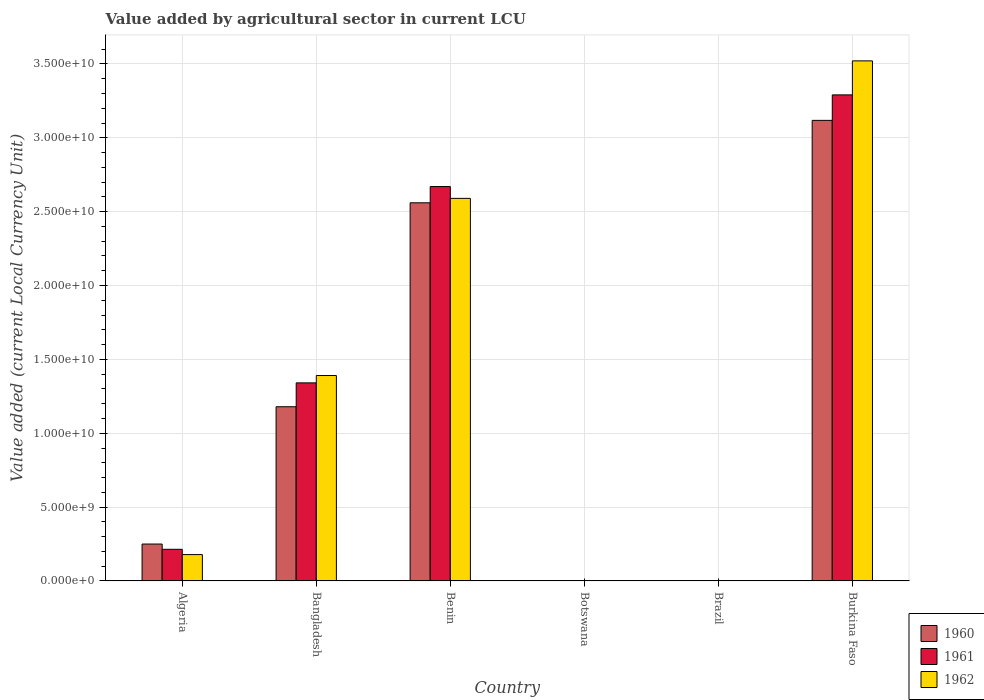How many different coloured bars are there?
Ensure brevity in your answer.  3. How many groups of bars are there?
Your response must be concise. 6. How many bars are there on the 4th tick from the right?
Ensure brevity in your answer.  3. What is the value added by agricultural sector in 1961 in Bangladesh?
Provide a succinct answer. 1.34e+1. Across all countries, what is the maximum value added by agricultural sector in 1962?
Offer a terse response. 3.52e+1. Across all countries, what is the minimum value added by agricultural sector in 1962?
Your response must be concise. 0. In which country was the value added by agricultural sector in 1961 maximum?
Provide a short and direct response. Burkina Faso. In which country was the value added by agricultural sector in 1960 minimum?
Give a very brief answer. Brazil. What is the total value added by agricultural sector in 1962 in the graph?
Offer a very short reply. 7.68e+1. What is the difference between the value added by agricultural sector in 1961 in Bangladesh and that in Burkina Faso?
Provide a short and direct response. -1.95e+1. What is the difference between the value added by agricultural sector in 1962 in Burkina Faso and the value added by agricultural sector in 1960 in Botswana?
Provide a succinct answer. 3.52e+1. What is the average value added by agricultural sector in 1960 per country?
Provide a succinct answer. 1.18e+1. What is the difference between the value added by agricultural sector of/in 1960 and value added by agricultural sector of/in 1961 in Burkina Faso?
Make the answer very short. -1.73e+09. In how many countries, is the value added by agricultural sector in 1962 greater than 24000000000 LCU?
Your answer should be compact. 2. What is the ratio of the value added by agricultural sector in 1960 in Algeria to that in Benin?
Make the answer very short. 0.1. Is the value added by agricultural sector in 1962 in Algeria less than that in Burkina Faso?
Keep it short and to the point. Yes. Is the difference between the value added by agricultural sector in 1960 in Bangladesh and Botswana greater than the difference between the value added by agricultural sector in 1961 in Bangladesh and Botswana?
Offer a terse response. No. What is the difference between the highest and the second highest value added by agricultural sector in 1961?
Keep it short and to the point. 6.21e+09. What is the difference between the highest and the lowest value added by agricultural sector in 1961?
Your response must be concise. 3.29e+1. Is the sum of the value added by agricultural sector in 1961 in Bangladesh and Benin greater than the maximum value added by agricultural sector in 1960 across all countries?
Offer a terse response. Yes. What does the 2nd bar from the right in Burkina Faso represents?
Offer a very short reply. 1961. How many countries are there in the graph?
Your answer should be very brief. 6. What is the difference between two consecutive major ticks on the Y-axis?
Offer a terse response. 5.00e+09. Does the graph contain any zero values?
Your response must be concise. No. How are the legend labels stacked?
Your answer should be compact. Vertical. What is the title of the graph?
Make the answer very short. Value added by agricultural sector in current LCU. What is the label or title of the Y-axis?
Your response must be concise. Value added (current Local Currency Unit). What is the Value added (current Local Currency Unit) of 1960 in Algeria?
Offer a very short reply. 2.50e+09. What is the Value added (current Local Currency Unit) in 1961 in Algeria?
Ensure brevity in your answer.  2.14e+09. What is the Value added (current Local Currency Unit) in 1962 in Algeria?
Offer a terse response. 1.78e+09. What is the Value added (current Local Currency Unit) of 1960 in Bangladesh?
Your answer should be very brief. 1.18e+1. What is the Value added (current Local Currency Unit) in 1961 in Bangladesh?
Your answer should be compact. 1.34e+1. What is the Value added (current Local Currency Unit) in 1962 in Bangladesh?
Your answer should be very brief. 1.39e+1. What is the Value added (current Local Currency Unit) of 1960 in Benin?
Offer a very short reply. 2.56e+1. What is the Value added (current Local Currency Unit) in 1961 in Benin?
Your response must be concise. 2.67e+1. What is the Value added (current Local Currency Unit) of 1962 in Benin?
Make the answer very short. 2.59e+1. What is the Value added (current Local Currency Unit) in 1960 in Botswana?
Your answer should be very brief. 9.38e+06. What is the Value added (current Local Currency Unit) in 1961 in Botswana?
Your response must be concise. 9.86e+06. What is the Value added (current Local Currency Unit) in 1962 in Botswana?
Offer a very short reply. 1.03e+07. What is the Value added (current Local Currency Unit) of 1960 in Brazil?
Keep it short and to the point. 0. What is the Value added (current Local Currency Unit) of 1961 in Brazil?
Keep it short and to the point. 0. What is the Value added (current Local Currency Unit) of 1962 in Brazil?
Offer a very short reply. 0. What is the Value added (current Local Currency Unit) of 1960 in Burkina Faso?
Your answer should be very brief. 3.12e+1. What is the Value added (current Local Currency Unit) in 1961 in Burkina Faso?
Your answer should be compact. 3.29e+1. What is the Value added (current Local Currency Unit) in 1962 in Burkina Faso?
Provide a succinct answer. 3.52e+1. Across all countries, what is the maximum Value added (current Local Currency Unit) of 1960?
Offer a terse response. 3.12e+1. Across all countries, what is the maximum Value added (current Local Currency Unit) in 1961?
Your answer should be compact. 3.29e+1. Across all countries, what is the maximum Value added (current Local Currency Unit) in 1962?
Provide a succinct answer. 3.52e+1. Across all countries, what is the minimum Value added (current Local Currency Unit) of 1960?
Provide a short and direct response. 0. Across all countries, what is the minimum Value added (current Local Currency Unit) in 1961?
Offer a very short reply. 0. Across all countries, what is the minimum Value added (current Local Currency Unit) of 1962?
Your answer should be compact. 0. What is the total Value added (current Local Currency Unit) in 1960 in the graph?
Your answer should be compact. 7.11e+1. What is the total Value added (current Local Currency Unit) in 1961 in the graph?
Give a very brief answer. 7.52e+1. What is the total Value added (current Local Currency Unit) of 1962 in the graph?
Your answer should be compact. 7.68e+1. What is the difference between the Value added (current Local Currency Unit) in 1960 in Algeria and that in Bangladesh?
Make the answer very short. -9.29e+09. What is the difference between the Value added (current Local Currency Unit) in 1961 in Algeria and that in Bangladesh?
Offer a terse response. -1.13e+1. What is the difference between the Value added (current Local Currency Unit) of 1962 in Algeria and that in Bangladesh?
Your answer should be compact. -1.21e+1. What is the difference between the Value added (current Local Currency Unit) in 1960 in Algeria and that in Benin?
Make the answer very short. -2.31e+1. What is the difference between the Value added (current Local Currency Unit) of 1961 in Algeria and that in Benin?
Make the answer very short. -2.46e+1. What is the difference between the Value added (current Local Currency Unit) of 1962 in Algeria and that in Benin?
Make the answer very short. -2.41e+1. What is the difference between the Value added (current Local Currency Unit) in 1960 in Algeria and that in Botswana?
Provide a succinct answer. 2.49e+09. What is the difference between the Value added (current Local Currency Unit) of 1961 in Algeria and that in Botswana?
Your answer should be compact. 2.13e+09. What is the difference between the Value added (current Local Currency Unit) in 1962 in Algeria and that in Botswana?
Provide a succinct answer. 1.77e+09. What is the difference between the Value added (current Local Currency Unit) in 1960 in Algeria and that in Brazil?
Your answer should be compact. 2.50e+09. What is the difference between the Value added (current Local Currency Unit) of 1961 in Algeria and that in Brazil?
Your response must be concise. 2.14e+09. What is the difference between the Value added (current Local Currency Unit) of 1962 in Algeria and that in Brazil?
Provide a short and direct response. 1.78e+09. What is the difference between the Value added (current Local Currency Unit) of 1960 in Algeria and that in Burkina Faso?
Provide a short and direct response. -2.87e+1. What is the difference between the Value added (current Local Currency Unit) in 1961 in Algeria and that in Burkina Faso?
Your answer should be compact. -3.08e+1. What is the difference between the Value added (current Local Currency Unit) of 1962 in Algeria and that in Burkina Faso?
Your answer should be very brief. -3.34e+1. What is the difference between the Value added (current Local Currency Unit) in 1960 in Bangladesh and that in Benin?
Offer a terse response. -1.38e+1. What is the difference between the Value added (current Local Currency Unit) in 1961 in Bangladesh and that in Benin?
Offer a terse response. -1.33e+1. What is the difference between the Value added (current Local Currency Unit) in 1962 in Bangladesh and that in Benin?
Ensure brevity in your answer.  -1.20e+1. What is the difference between the Value added (current Local Currency Unit) of 1960 in Bangladesh and that in Botswana?
Offer a terse response. 1.18e+1. What is the difference between the Value added (current Local Currency Unit) of 1961 in Bangladesh and that in Botswana?
Provide a succinct answer. 1.34e+1. What is the difference between the Value added (current Local Currency Unit) of 1962 in Bangladesh and that in Botswana?
Make the answer very short. 1.39e+1. What is the difference between the Value added (current Local Currency Unit) in 1960 in Bangladesh and that in Brazil?
Your answer should be very brief. 1.18e+1. What is the difference between the Value added (current Local Currency Unit) in 1961 in Bangladesh and that in Brazil?
Your answer should be compact. 1.34e+1. What is the difference between the Value added (current Local Currency Unit) in 1962 in Bangladesh and that in Brazil?
Keep it short and to the point. 1.39e+1. What is the difference between the Value added (current Local Currency Unit) of 1960 in Bangladesh and that in Burkina Faso?
Your response must be concise. -1.94e+1. What is the difference between the Value added (current Local Currency Unit) of 1961 in Bangladesh and that in Burkina Faso?
Give a very brief answer. -1.95e+1. What is the difference between the Value added (current Local Currency Unit) of 1962 in Bangladesh and that in Burkina Faso?
Ensure brevity in your answer.  -2.13e+1. What is the difference between the Value added (current Local Currency Unit) of 1960 in Benin and that in Botswana?
Make the answer very short. 2.56e+1. What is the difference between the Value added (current Local Currency Unit) of 1961 in Benin and that in Botswana?
Make the answer very short. 2.67e+1. What is the difference between the Value added (current Local Currency Unit) in 1962 in Benin and that in Botswana?
Give a very brief answer. 2.59e+1. What is the difference between the Value added (current Local Currency Unit) of 1960 in Benin and that in Brazil?
Your answer should be compact. 2.56e+1. What is the difference between the Value added (current Local Currency Unit) of 1961 in Benin and that in Brazil?
Keep it short and to the point. 2.67e+1. What is the difference between the Value added (current Local Currency Unit) in 1962 in Benin and that in Brazil?
Give a very brief answer. 2.59e+1. What is the difference between the Value added (current Local Currency Unit) in 1960 in Benin and that in Burkina Faso?
Your response must be concise. -5.58e+09. What is the difference between the Value added (current Local Currency Unit) of 1961 in Benin and that in Burkina Faso?
Your answer should be very brief. -6.21e+09. What is the difference between the Value added (current Local Currency Unit) of 1962 in Benin and that in Burkina Faso?
Your response must be concise. -9.31e+09. What is the difference between the Value added (current Local Currency Unit) in 1960 in Botswana and that in Brazil?
Provide a succinct answer. 9.38e+06. What is the difference between the Value added (current Local Currency Unit) in 1961 in Botswana and that in Brazil?
Your answer should be compact. 9.86e+06. What is the difference between the Value added (current Local Currency Unit) of 1962 in Botswana and that in Brazil?
Provide a succinct answer. 1.03e+07. What is the difference between the Value added (current Local Currency Unit) of 1960 in Botswana and that in Burkina Faso?
Your answer should be compact. -3.12e+1. What is the difference between the Value added (current Local Currency Unit) in 1961 in Botswana and that in Burkina Faso?
Provide a succinct answer. -3.29e+1. What is the difference between the Value added (current Local Currency Unit) in 1962 in Botswana and that in Burkina Faso?
Make the answer very short. -3.52e+1. What is the difference between the Value added (current Local Currency Unit) of 1960 in Brazil and that in Burkina Faso?
Your response must be concise. -3.12e+1. What is the difference between the Value added (current Local Currency Unit) of 1961 in Brazil and that in Burkina Faso?
Provide a short and direct response. -3.29e+1. What is the difference between the Value added (current Local Currency Unit) of 1962 in Brazil and that in Burkina Faso?
Your answer should be compact. -3.52e+1. What is the difference between the Value added (current Local Currency Unit) in 1960 in Algeria and the Value added (current Local Currency Unit) in 1961 in Bangladesh?
Give a very brief answer. -1.09e+1. What is the difference between the Value added (current Local Currency Unit) of 1960 in Algeria and the Value added (current Local Currency Unit) of 1962 in Bangladesh?
Your response must be concise. -1.14e+1. What is the difference between the Value added (current Local Currency Unit) in 1961 in Algeria and the Value added (current Local Currency Unit) in 1962 in Bangladesh?
Your answer should be compact. -1.18e+1. What is the difference between the Value added (current Local Currency Unit) of 1960 in Algeria and the Value added (current Local Currency Unit) of 1961 in Benin?
Ensure brevity in your answer.  -2.42e+1. What is the difference between the Value added (current Local Currency Unit) of 1960 in Algeria and the Value added (current Local Currency Unit) of 1962 in Benin?
Offer a very short reply. -2.34e+1. What is the difference between the Value added (current Local Currency Unit) of 1961 in Algeria and the Value added (current Local Currency Unit) of 1962 in Benin?
Your answer should be compact. -2.38e+1. What is the difference between the Value added (current Local Currency Unit) in 1960 in Algeria and the Value added (current Local Currency Unit) in 1961 in Botswana?
Ensure brevity in your answer.  2.49e+09. What is the difference between the Value added (current Local Currency Unit) of 1960 in Algeria and the Value added (current Local Currency Unit) of 1962 in Botswana?
Give a very brief answer. 2.49e+09. What is the difference between the Value added (current Local Currency Unit) in 1961 in Algeria and the Value added (current Local Currency Unit) in 1962 in Botswana?
Your response must be concise. 2.13e+09. What is the difference between the Value added (current Local Currency Unit) in 1960 in Algeria and the Value added (current Local Currency Unit) in 1961 in Brazil?
Your answer should be very brief. 2.50e+09. What is the difference between the Value added (current Local Currency Unit) in 1960 in Algeria and the Value added (current Local Currency Unit) in 1962 in Brazil?
Make the answer very short. 2.50e+09. What is the difference between the Value added (current Local Currency Unit) of 1961 in Algeria and the Value added (current Local Currency Unit) of 1962 in Brazil?
Ensure brevity in your answer.  2.14e+09. What is the difference between the Value added (current Local Currency Unit) in 1960 in Algeria and the Value added (current Local Currency Unit) in 1961 in Burkina Faso?
Give a very brief answer. -3.04e+1. What is the difference between the Value added (current Local Currency Unit) in 1960 in Algeria and the Value added (current Local Currency Unit) in 1962 in Burkina Faso?
Your answer should be very brief. -3.27e+1. What is the difference between the Value added (current Local Currency Unit) of 1961 in Algeria and the Value added (current Local Currency Unit) of 1962 in Burkina Faso?
Give a very brief answer. -3.31e+1. What is the difference between the Value added (current Local Currency Unit) of 1960 in Bangladesh and the Value added (current Local Currency Unit) of 1961 in Benin?
Ensure brevity in your answer.  -1.49e+1. What is the difference between the Value added (current Local Currency Unit) in 1960 in Bangladesh and the Value added (current Local Currency Unit) in 1962 in Benin?
Give a very brief answer. -1.41e+1. What is the difference between the Value added (current Local Currency Unit) in 1961 in Bangladesh and the Value added (current Local Currency Unit) in 1962 in Benin?
Offer a terse response. -1.25e+1. What is the difference between the Value added (current Local Currency Unit) in 1960 in Bangladesh and the Value added (current Local Currency Unit) in 1961 in Botswana?
Ensure brevity in your answer.  1.18e+1. What is the difference between the Value added (current Local Currency Unit) in 1960 in Bangladesh and the Value added (current Local Currency Unit) in 1962 in Botswana?
Offer a very short reply. 1.18e+1. What is the difference between the Value added (current Local Currency Unit) of 1961 in Bangladesh and the Value added (current Local Currency Unit) of 1962 in Botswana?
Offer a very short reply. 1.34e+1. What is the difference between the Value added (current Local Currency Unit) of 1960 in Bangladesh and the Value added (current Local Currency Unit) of 1961 in Brazil?
Your response must be concise. 1.18e+1. What is the difference between the Value added (current Local Currency Unit) of 1960 in Bangladesh and the Value added (current Local Currency Unit) of 1962 in Brazil?
Offer a very short reply. 1.18e+1. What is the difference between the Value added (current Local Currency Unit) of 1961 in Bangladesh and the Value added (current Local Currency Unit) of 1962 in Brazil?
Your response must be concise. 1.34e+1. What is the difference between the Value added (current Local Currency Unit) in 1960 in Bangladesh and the Value added (current Local Currency Unit) in 1961 in Burkina Faso?
Your answer should be very brief. -2.11e+1. What is the difference between the Value added (current Local Currency Unit) in 1960 in Bangladesh and the Value added (current Local Currency Unit) in 1962 in Burkina Faso?
Provide a short and direct response. -2.34e+1. What is the difference between the Value added (current Local Currency Unit) of 1961 in Bangladesh and the Value added (current Local Currency Unit) of 1962 in Burkina Faso?
Offer a very short reply. -2.18e+1. What is the difference between the Value added (current Local Currency Unit) of 1960 in Benin and the Value added (current Local Currency Unit) of 1961 in Botswana?
Your response must be concise. 2.56e+1. What is the difference between the Value added (current Local Currency Unit) in 1960 in Benin and the Value added (current Local Currency Unit) in 1962 in Botswana?
Provide a succinct answer. 2.56e+1. What is the difference between the Value added (current Local Currency Unit) in 1961 in Benin and the Value added (current Local Currency Unit) in 1962 in Botswana?
Your response must be concise. 2.67e+1. What is the difference between the Value added (current Local Currency Unit) in 1960 in Benin and the Value added (current Local Currency Unit) in 1961 in Brazil?
Offer a very short reply. 2.56e+1. What is the difference between the Value added (current Local Currency Unit) of 1960 in Benin and the Value added (current Local Currency Unit) of 1962 in Brazil?
Offer a very short reply. 2.56e+1. What is the difference between the Value added (current Local Currency Unit) in 1961 in Benin and the Value added (current Local Currency Unit) in 1962 in Brazil?
Give a very brief answer. 2.67e+1. What is the difference between the Value added (current Local Currency Unit) of 1960 in Benin and the Value added (current Local Currency Unit) of 1961 in Burkina Faso?
Your response must be concise. -7.31e+09. What is the difference between the Value added (current Local Currency Unit) in 1960 in Benin and the Value added (current Local Currency Unit) in 1962 in Burkina Faso?
Offer a terse response. -9.61e+09. What is the difference between the Value added (current Local Currency Unit) of 1961 in Benin and the Value added (current Local Currency Unit) of 1962 in Burkina Faso?
Offer a terse response. -8.51e+09. What is the difference between the Value added (current Local Currency Unit) of 1960 in Botswana and the Value added (current Local Currency Unit) of 1961 in Brazil?
Offer a very short reply. 9.38e+06. What is the difference between the Value added (current Local Currency Unit) in 1960 in Botswana and the Value added (current Local Currency Unit) in 1962 in Brazil?
Your response must be concise. 9.38e+06. What is the difference between the Value added (current Local Currency Unit) in 1961 in Botswana and the Value added (current Local Currency Unit) in 1962 in Brazil?
Your answer should be compact. 9.86e+06. What is the difference between the Value added (current Local Currency Unit) of 1960 in Botswana and the Value added (current Local Currency Unit) of 1961 in Burkina Faso?
Provide a succinct answer. -3.29e+1. What is the difference between the Value added (current Local Currency Unit) in 1960 in Botswana and the Value added (current Local Currency Unit) in 1962 in Burkina Faso?
Ensure brevity in your answer.  -3.52e+1. What is the difference between the Value added (current Local Currency Unit) of 1961 in Botswana and the Value added (current Local Currency Unit) of 1962 in Burkina Faso?
Keep it short and to the point. -3.52e+1. What is the difference between the Value added (current Local Currency Unit) in 1960 in Brazil and the Value added (current Local Currency Unit) in 1961 in Burkina Faso?
Your answer should be compact. -3.29e+1. What is the difference between the Value added (current Local Currency Unit) in 1960 in Brazil and the Value added (current Local Currency Unit) in 1962 in Burkina Faso?
Provide a succinct answer. -3.52e+1. What is the difference between the Value added (current Local Currency Unit) in 1961 in Brazil and the Value added (current Local Currency Unit) in 1962 in Burkina Faso?
Ensure brevity in your answer.  -3.52e+1. What is the average Value added (current Local Currency Unit) in 1960 per country?
Your response must be concise. 1.18e+1. What is the average Value added (current Local Currency Unit) in 1961 per country?
Your answer should be very brief. 1.25e+1. What is the average Value added (current Local Currency Unit) in 1962 per country?
Give a very brief answer. 1.28e+1. What is the difference between the Value added (current Local Currency Unit) of 1960 and Value added (current Local Currency Unit) of 1961 in Algeria?
Offer a terse response. 3.57e+08. What is the difference between the Value added (current Local Currency Unit) of 1960 and Value added (current Local Currency Unit) of 1962 in Algeria?
Your response must be concise. 7.14e+08. What is the difference between the Value added (current Local Currency Unit) in 1961 and Value added (current Local Currency Unit) in 1962 in Algeria?
Provide a short and direct response. 3.57e+08. What is the difference between the Value added (current Local Currency Unit) of 1960 and Value added (current Local Currency Unit) of 1961 in Bangladesh?
Provide a short and direct response. -1.62e+09. What is the difference between the Value added (current Local Currency Unit) of 1960 and Value added (current Local Currency Unit) of 1962 in Bangladesh?
Your answer should be very brief. -2.11e+09. What is the difference between the Value added (current Local Currency Unit) in 1961 and Value added (current Local Currency Unit) in 1962 in Bangladesh?
Your answer should be very brief. -4.98e+08. What is the difference between the Value added (current Local Currency Unit) of 1960 and Value added (current Local Currency Unit) of 1961 in Benin?
Make the answer very short. -1.10e+09. What is the difference between the Value added (current Local Currency Unit) in 1960 and Value added (current Local Currency Unit) in 1962 in Benin?
Offer a terse response. -3.00e+08. What is the difference between the Value added (current Local Currency Unit) in 1961 and Value added (current Local Currency Unit) in 1962 in Benin?
Keep it short and to the point. 8.00e+08. What is the difference between the Value added (current Local Currency Unit) of 1960 and Value added (current Local Currency Unit) of 1961 in Botswana?
Your answer should be compact. -4.83e+05. What is the difference between the Value added (current Local Currency Unit) of 1960 and Value added (current Local Currency Unit) of 1962 in Botswana?
Make the answer very short. -9.65e+05. What is the difference between the Value added (current Local Currency Unit) of 1961 and Value added (current Local Currency Unit) of 1962 in Botswana?
Your answer should be compact. -4.83e+05. What is the difference between the Value added (current Local Currency Unit) in 1960 and Value added (current Local Currency Unit) in 1961 in Brazil?
Provide a succinct answer. -0. What is the difference between the Value added (current Local Currency Unit) in 1960 and Value added (current Local Currency Unit) in 1962 in Brazil?
Make the answer very short. -0. What is the difference between the Value added (current Local Currency Unit) in 1961 and Value added (current Local Currency Unit) in 1962 in Brazil?
Make the answer very short. -0. What is the difference between the Value added (current Local Currency Unit) of 1960 and Value added (current Local Currency Unit) of 1961 in Burkina Faso?
Provide a short and direct response. -1.73e+09. What is the difference between the Value added (current Local Currency Unit) of 1960 and Value added (current Local Currency Unit) of 1962 in Burkina Faso?
Offer a terse response. -4.03e+09. What is the difference between the Value added (current Local Currency Unit) of 1961 and Value added (current Local Currency Unit) of 1962 in Burkina Faso?
Make the answer very short. -2.30e+09. What is the ratio of the Value added (current Local Currency Unit) of 1960 in Algeria to that in Bangladesh?
Provide a short and direct response. 0.21. What is the ratio of the Value added (current Local Currency Unit) of 1961 in Algeria to that in Bangladesh?
Your answer should be compact. 0.16. What is the ratio of the Value added (current Local Currency Unit) in 1962 in Algeria to that in Bangladesh?
Your response must be concise. 0.13. What is the ratio of the Value added (current Local Currency Unit) of 1960 in Algeria to that in Benin?
Your answer should be very brief. 0.1. What is the ratio of the Value added (current Local Currency Unit) of 1961 in Algeria to that in Benin?
Your answer should be compact. 0.08. What is the ratio of the Value added (current Local Currency Unit) in 1962 in Algeria to that in Benin?
Your response must be concise. 0.07. What is the ratio of the Value added (current Local Currency Unit) of 1960 in Algeria to that in Botswana?
Ensure brevity in your answer.  266.47. What is the ratio of the Value added (current Local Currency Unit) in 1961 in Algeria to that in Botswana?
Your response must be concise. 217.22. What is the ratio of the Value added (current Local Currency Unit) of 1962 in Algeria to that in Botswana?
Offer a terse response. 172.57. What is the ratio of the Value added (current Local Currency Unit) in 1960 in Algeria to that in Brazil?
Ensure brevity in your answer.  1.37e+13. What is the ratio of the Value added (current Local Currency Unit) of 1961 in Algeria to that in Brazil?
Offer a very short reply. 8.40e+12. What is the ratio of the Value added (current Local Currency Unit) in 1962 in Algeria to that in Brazil?
Offer a terse response. 4.09e+12. What is the ratio of the Value added (current Local Currency Unit) of 1960 in Algeria to that in Burkina Faso?
Offer a very short reply. 0.08. What is the ratio of the Value added (current Local Currency Unit) of 1961 in Algeria to that in Burkina Faso?
Your answer should be very brief. 0.07. What is the ratio of the Value added (current Local Currency Unit) in 1962 in Algeria to that in Burkina Faso?
Your answer should be very brief. 0.05. What is the ratio of the Value added (current Local Currency Unit) in 1960 in Bangladesh to that in Benin?
Offer a very short reply. 0.46. What is the ratio of the Value added (current Local Currency Unit) in 1961 in Bangladesh to that in Benin?
Make the answer very short. 0.5. What is the ratio of the Value added (current Local Currency Unit) in 1962 in Bangladesh to that in Benin?
Your answer should be very brief. 0.54. What is the ratio of the Value added (current Local Currency Unit) of 1960 in Bangladesh to that in Botswana?
Provide a short and direct response. 1257.78. What is the ratio of the Value added (current Local Currency Unit) in 1961 in Bangladesh to that in Botswana?
Your answer should be very brief. 1360.12. What is the ratio of the Value added (current Local Currency Unit) of 1962 in Bangladesh to that in Botswana?
Ensure brevity in your answer.  1344.79. What is the ratio of the Value added (current Local Currency Unit) of 1960 in Bangladesh to that in Brazil?
Your response must be concise. 6.48e+13. What is the ratio of the Value added (current Local Currency Unit) in 1961 in Bangladesh to that in Brazil?
Ensure brevity in your answer.  5.26e+13. What is the ratio of the Value added (current Local Currency Unit) of 1962 in Bangladesh to that in Brazil?
Provide a succinct answer. 3.19e+13. What is the ratio of the Value added (current Local Currency Unit) of 1960 in Bangladesh to that in Burkina Faso?
Your answer should be very brief. 0.38. What is the ratio of the Value added (current Local Currency Unit) in 1961 in Bangladesh to that in Burkina Faso?
Make the answer very short. 0.41. What is the ratio of the Value added (current Local Currency Unit) in 1962 in Bangladesh to that in Burkina Faso?
Provide a succinct answer. 0.4. What is the ratio of the Value added (current Local Currency Unit) in 1960 in Benin to that in Botswana?
Your response must be concise. 2730.26. What is the ratio of the Value added (current Local Currency Unit) of 1961 in Benin to that in Botswana?
Offer a very short reply. 2708.19. What is the ratio of the Value added (current Local Currency Unit) in 1962 in Benin to that in Botswana?
Make the answer very short. 2504.45. What is the ratio of the Value added (current Local Currency Unit) of 1960 in Benin to that in Brazil?
Offer a terse response. 1.41e+14. What is the ratio of the Value added (current Local Currency Unit) in 1961 in Benin to that in Brazil?
Provide a succinct answer. 1.05e+14. What is the ratio of the Value added (current Local Currency Unit) in 1962 in Benin to that in Brazil?
Ensure brevity in your answer.  5.94e+13. What is the ratio of the Value added (current Local Currency Unit) of 1960 in Benin to that in Burkina Faso?
Your answer should be very brief. 0.82. What is the ratio of the Value added (current Local Currency Unit) in 1961 in Benin to that in Burkina Faso?
Your response must be concise. 0.81. What is the ratio of the Value added (current Local Currency Unit) of 1962 in Benin to that in Burkina Faso?
Provide a short and direct response. 0.74. What is the ratio of the Value added (current Local Currency Unit) in 1960 in Botswana to that in Brazil?
Offer a very short reply. 5.15e+1. What is the ratio of the Value added (current Local Currency Unit) in 1961 in Botswana to that in Brazil?
Offer a very short reply. 3.86e+1. What is the ratio of the Value added (current Local Currency Unit) of 1962 in Botswana to that in Brazil?
Your response must be concise. 2.37e+1. What is the ratio of the Value added (current Local Currency Unit) in 1961 in Botswana to that in Burkina Faso?
Offer a terse response. 0. What is the ratio of the Value added (current Local Currency Unit) in 1960 in Brazil to that in Burkina Faso?
Keep it short and to the point. 0. What is the difference between the highest and the second highest Value added (current Local Currency Unit) of 1960?
Give a very brief answer. 5.58e+09. What is the difference between the highest and the second highest Value added (current Local Currency Unit) of 1961?
Give a very brief answer. 6.21e+09. What is the difference between the highest and the second highest Value added (current Local Currency Unit) in 1962?
Make the answer very short. 9.31e+09. What is the difference between the highest and the lowest Value added (current Local Currency Unit) of 1960?
Offer a very short reply. 3.12e+1. What is the difference between the highest and the lowest Value added (current Local Currency Unit) in 1961?
Provide a short and direct response. 3.29e+1. What is the difference between the highest and the lowest Value added (current Local Currency Unit) of 1962?
Your answer should be very brief. 3.52e+1. 